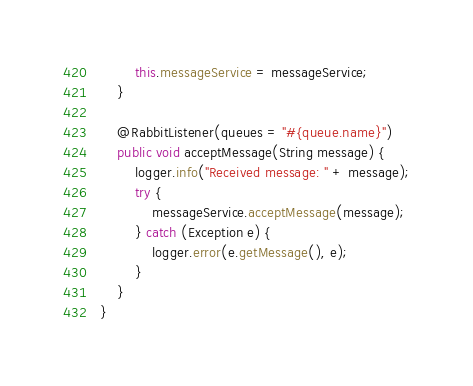Convert code to text. <code><loc_0><loc_0><loc_500><loc_500><_Java_>        this.messageService = messageService;
    }

    @RabbitListener(queues = "#{queue.name}")
    public void acceptMessage(String message) {
        logger.info("Received message: " + message);
        try {
            messageService.acceptMessage(message);
        } catch (Exception e) {
            logger.error(e.getMessage(), e);
        }
    }
}
</code> 